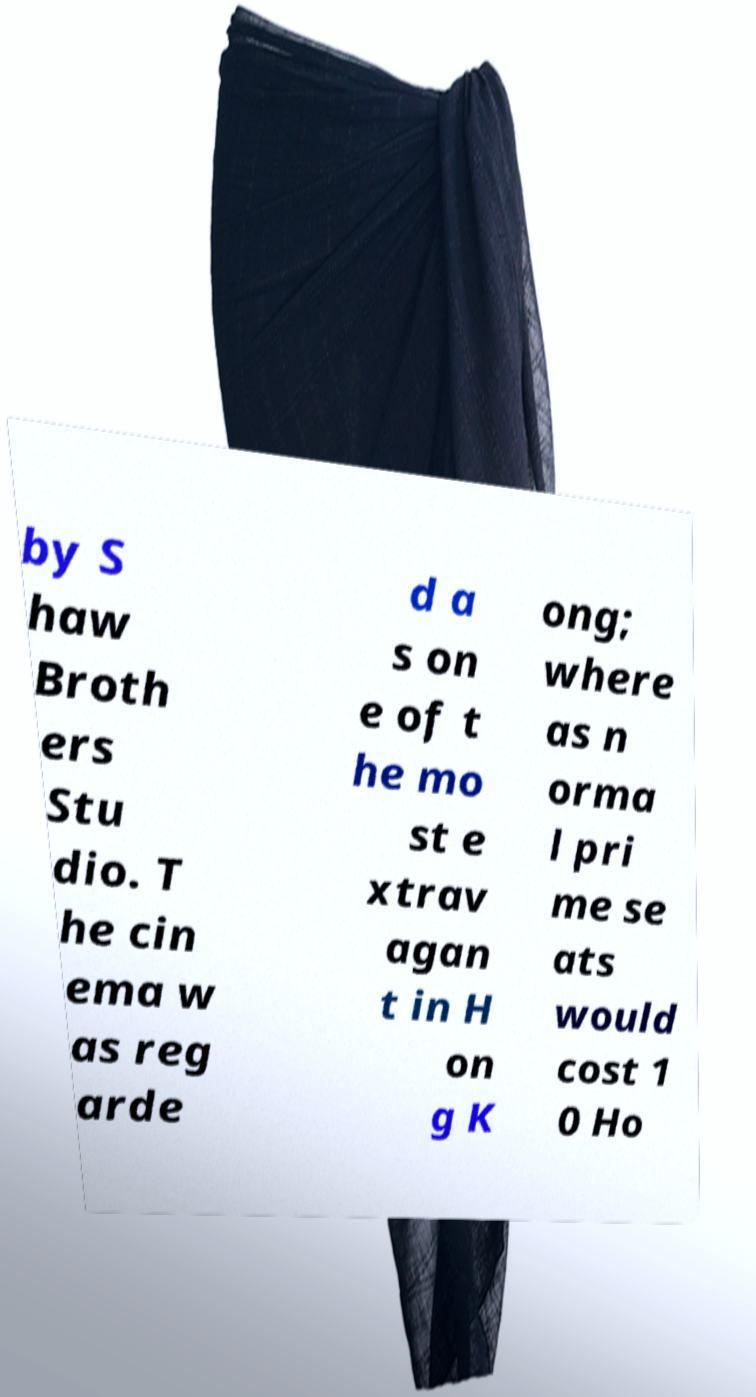What messages or text are displayed in this image? I need them in a readable, typed format. by S haw Broth ers Stu dio. T he cin ema w as reg arde d a s on e of t he mo st e xtrav agan t in H on g K ong; where as n orma l pri me se ats would cost 1 0 Ho 